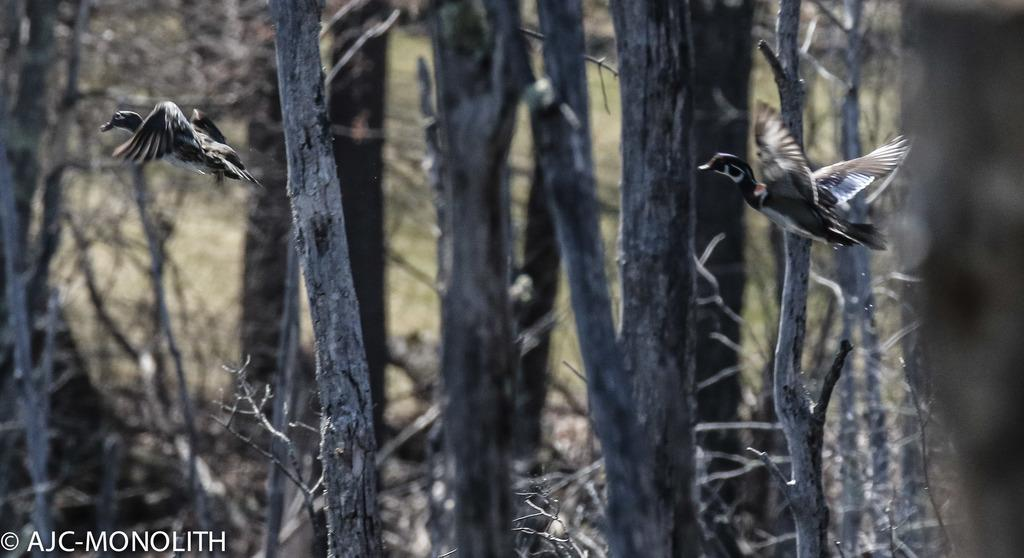What is happening in the sky in the image? There are birds flying in the sky in the image. What can be seen in the background of the image? There is a group of trees in the background. Is there any text present in the image? Yes, there is some text visible at the bottom of the image. What advice is the pail giving to the hole in the image? There is no pail or hole present in the image, so no advice can be given. 